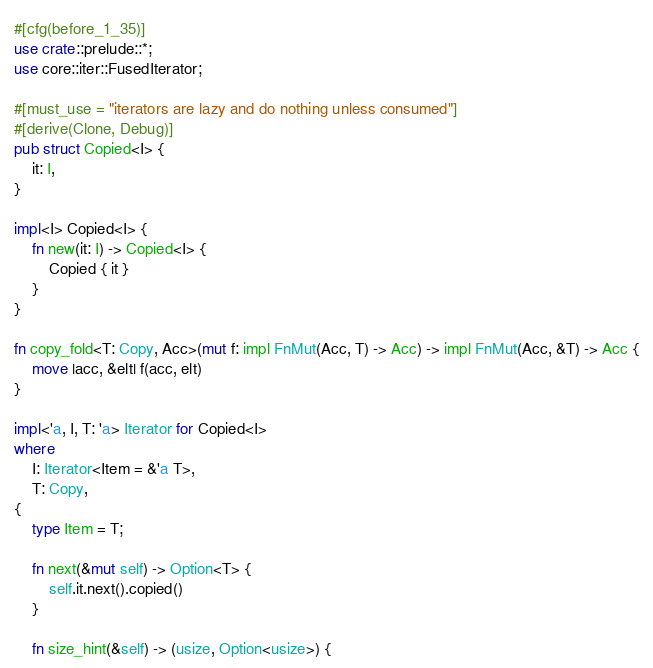Convert code to text. <code><loc_0><loc_0><loc_500><loc_500><_Rust_>#[cfg(before_1_35)]
use crate::prelude::*;
use core::iter::FusedIterator;

#[must_use = "iterators are lazy and do nothing unless consumed"]
#[derive(Clone, Debug)]
pub struct Copied<I> {
    it: I,
}

impl<I> Copied<I> {
    fn new(it: I) -> Copied<I> {
        Copied { it }
    }
}

fn copy_fold<T: Copy, Acc>(mut f: impl FnMut(Acc, T) -> Acc) -> impl FnMut(Acc, &T) -> Acc {
    move |acc, &elt| f(acc, elt)
}

impl<'a, I, T: 'a> Iterator for Copied<I>
where
    I: Iterator<Item = &'a T>,
    T: Copy,
{
    type Item = T;

    fn next(&mut self) -> Option<T> {
        self.it.next().copied()
    }

    fn size_hint(&self) -> (usize, Option<usize>) {</code> 